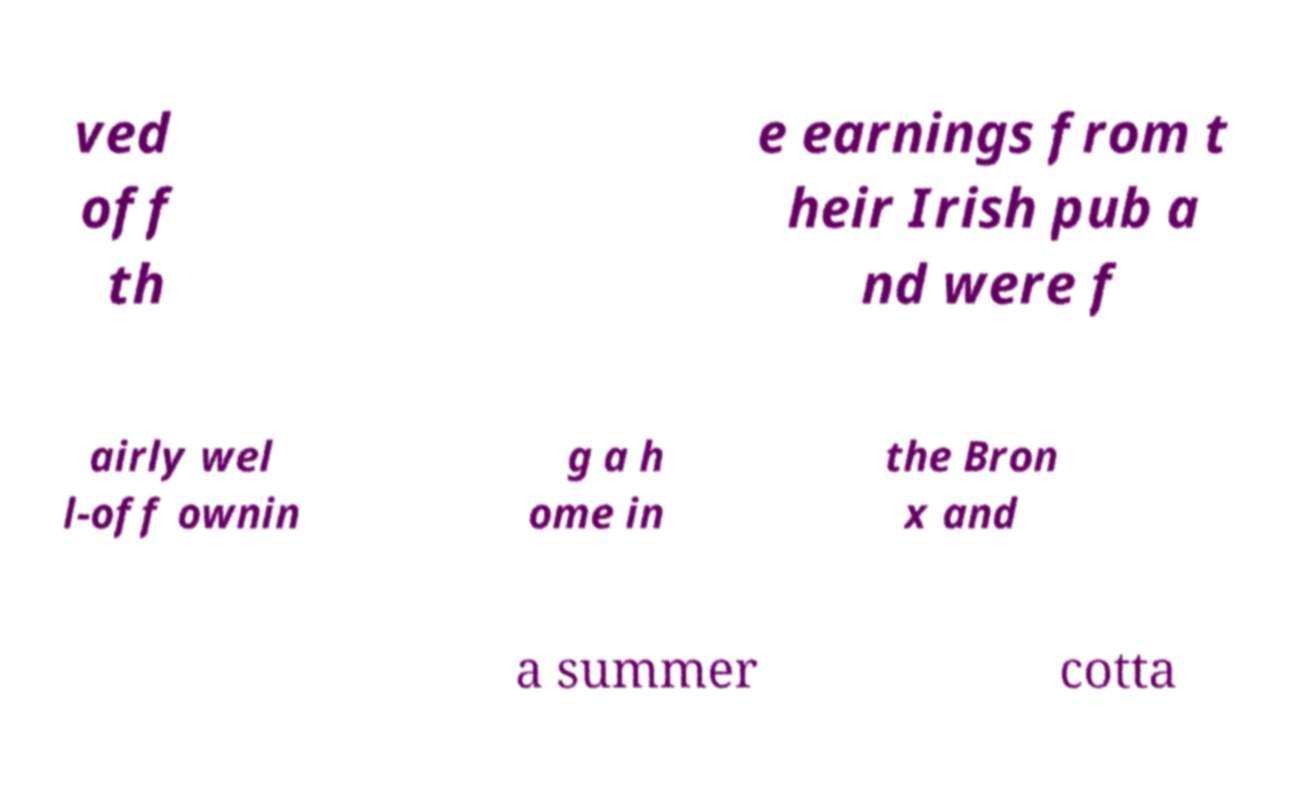Can you read and provide the text displayed in the image?This photo seems to have some interesting text. Can you extract and type it out for me? ved off th e earnings from t heir Irish pub a nd were f airly wel l-off ownin g a h ome in the Bron x and a summer cotta 